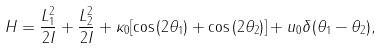Convert formula to latex. <formula><loc_0><loc_0><loc_500><loc_500>H = \frac { L _ { 1 } ^ { 2 } } { 2 I } + \frac { L _ { 2 } ^ { 2 } } { 2 I } + \kappa _ { 0 } [ \cos { ( 2 { \theta } _ { 1 } ) } + \cos { ( 2 { \theta } _ { 2 } ) } ] + u _ { 0 } \delta ( { \theta } _ { 1 } - { \theta } _ { 2 } ) ,</formula> 